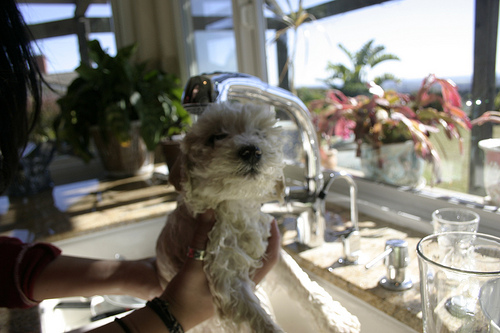<image>
Is the dog in the sink? Yes. The dog is contained within or inside the sink, showing a containment relationship. 